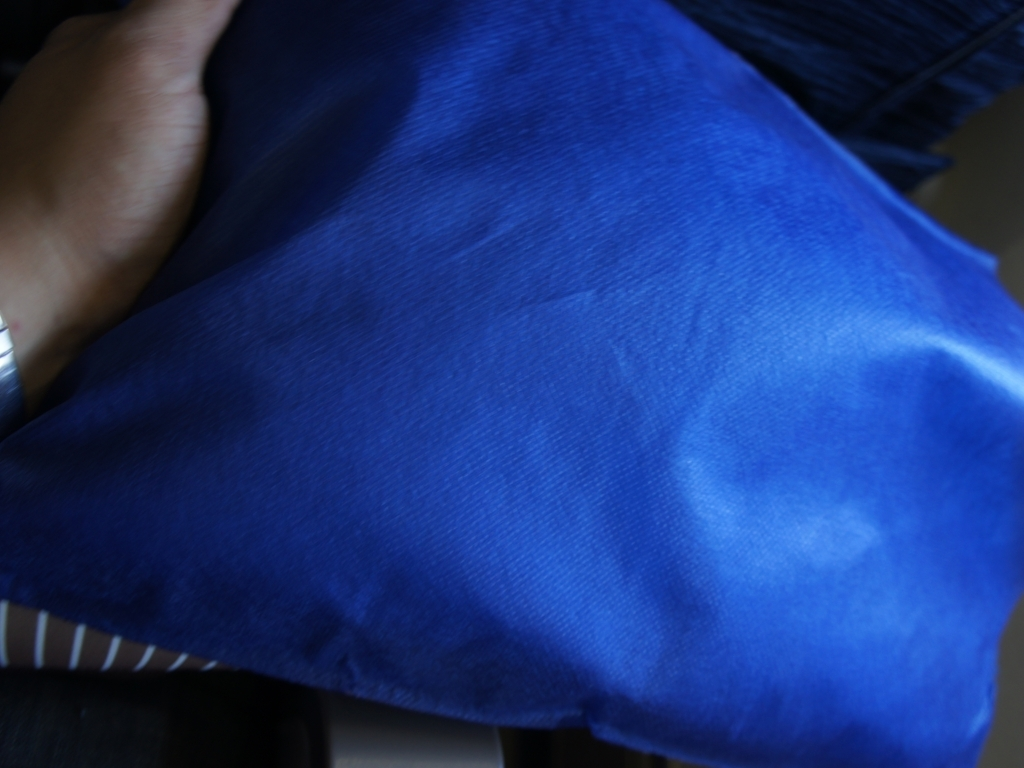Is the background bright and well-defined? Although the image appears to be slightly blurred and lacks focus, the overall impression is that the background is not bright and well-defined, hence the answer 'B. No' would have been more accurate if it was supplemented with this description. 